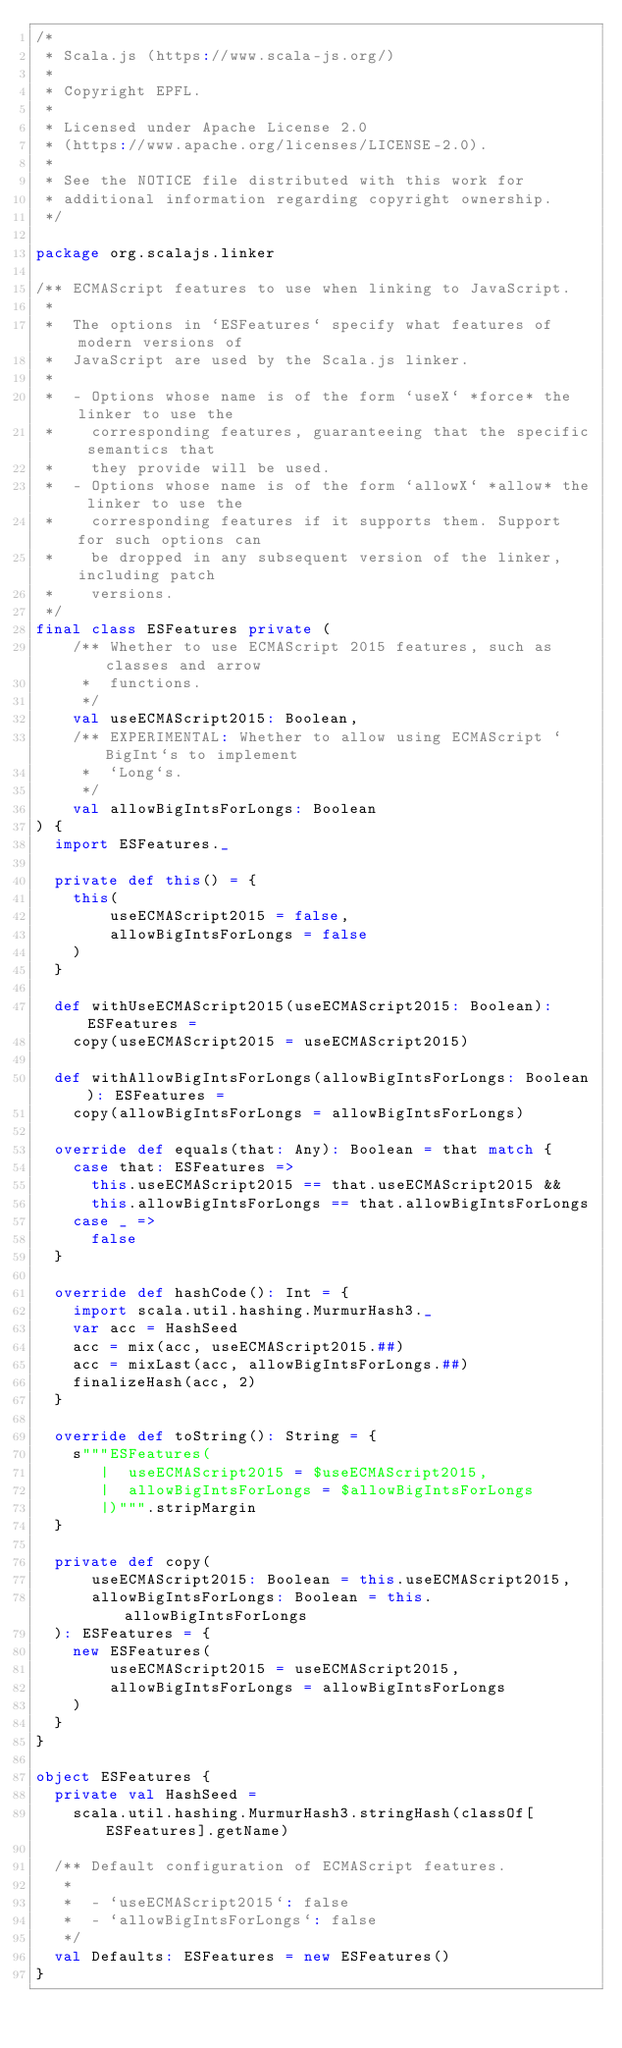<code> <loc_0><loc_0><loc_500><loc_500><_Scala_>/*
 * Scala.js (https://www.scala-js.org/)
 *
 * Copyright EPFL.
 *
 * Licensed under Apache License 2.0
 * (https://www.apache.org/licenses/LICENSE-2.0).
 *
 * See the NOTICE file distributed with this work for
 * additional information regarding copyright ownership.
 */

package org.scalajs.linker

/** ECMAScript features to use when linking to JavaScript.
 *
 *  The options in `ESFeatures` specify what features of modern versions of
 *  JavaScript are used by the Scala.js linker.
 *
 *  - Options whose name is of the form `useX` *force* the linker to use the
 *    corresponding features, guaranteeing that the specific semantics that
 *    they provide will be used.
 *  - Options whose name is of the form `allowX` *allow* the linker to use the
 *    corresponding features if it supports them. Support for such options can
 *    be dropped in any subsequent version of the linker, including patch
 *    versions.
 */
final class ESFeatures private (
    /** Whether to use ECMAScript 2015 features, such as classes and arrow
     *  functions.
     */
    val useECMAScript2015: Boolean,
    /** EXPERIMENTAL: Whether to allow using ECMAScript `BigInt`s to implement
     *  `Long`s.
     */
    val allowBigIntsForLongs: Boolean
) {
  import ESFeatures._

  private def this() = {
    this(
        useECMAScript2015 = false,
        allowBigIntsForLongs = false
    )
  }

  def withUseECMAScript2015(useECMAScript2015: Boolean): ESFeatures =
    copy(useECMAScript2015 = useECMAScript2015)

  def withAllowBigIntsForLongs(allowBigIntsForLongs: Boolean): ESFeatures =
    copy(allowBigIntsForLongs = allowBigIntsForLongs)

  override def equals(that: Any): Boolean = that match {
    case that: ESFeatures =>
      this.useECMAScript2015 == that.useECMAScript2015 &&
      this.allowBigIntsForLongs == that.allowBigIntsForLongs
    case _ =>
      false
  }

  override def hashCode(): Int = {
    import scala.util.hashing.MurmurHash3._
    var acc = HashSeed
    acc = mix(acc, useECMAScript2015.##)
    acc = mixLast(acc, allowBigIntsForLongs.##)
    finalizeHash(acc, 2)
  }

  override def toString(): String = {
    s"""ESFeatures(
       |  useECMAScript2015 = $useECMAScript2015,
       |  allowBigIntsForLongs = $allowBigIntsForLongs
       |)""".stripMargin
  }

  private def copy(
      useECMAScript2015: Boolean = this.useECMAScript2015,
      allowBigIntsForLongs: Boolean = this.allowBigIntsForLongs
  ): ESFeatures = {
    new ESFeatures(
        useECMAScript2015 = useECMAScript2015,
        allowBigIntsForLongs = allowBigIntsForLongs
    )
  }
}

object ESFeatures {
  private val HashSeed =
    scala.util.hashing.MurmurHash3.stringHash(classOf[ESFeatures].getName)

  /** Default configuration of ECMAScript features.
   *
   *  - `useECMAScript2015`: false
   *  - `allowBigIntsForLongs`: false
   */
  val Defaults: ESFeatures = new ESFeatures()
}
</code> 